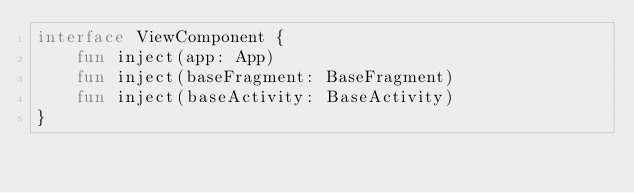Convert code to text. <code><loc_0><loc_0><loc_500><loc_500><_Kotlin_>interface ViewComponent {
    fun inject(app: App)
    fun inject(baseFragment: BaseFragment)
    fun inject(baseActivity: BaseActivity)
}
</code> 